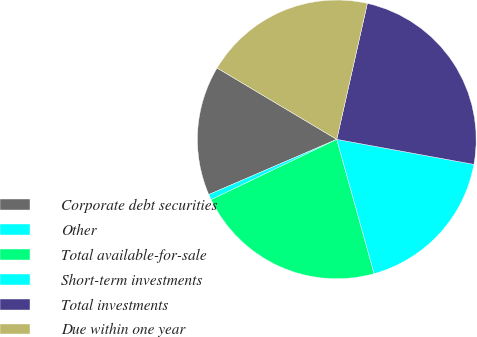Convert chart to OTSL. <chart><loc_0><loc_0><loc_500><loc_500><pie_chart><fcel>Corporate debt securities<fcel>Other<fcel>Total available-for-sale<fcel>Short-term investments<fcel>Total investments<fcel>Due within one year<nl><fcel>15.04%<fcel>0.64%<fcel>22.2%<fcel>17.81%<fcel>24.35%<fcel>19.96%<nl></chart> 